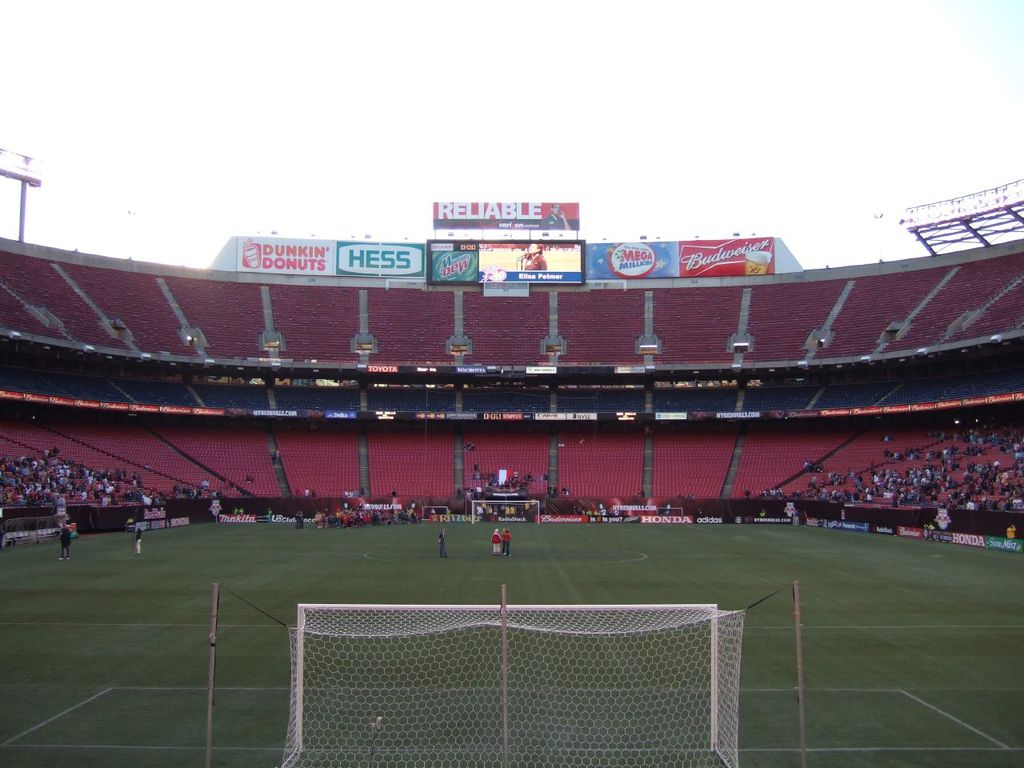Provide a one-sentence caption for the provided image. An expansive view of a stadium during a soccer match, featuring prominent advertisements for Dunkin Donuts, Hess, and other brands, illustrating a blend of sports culture and commercial presence. 